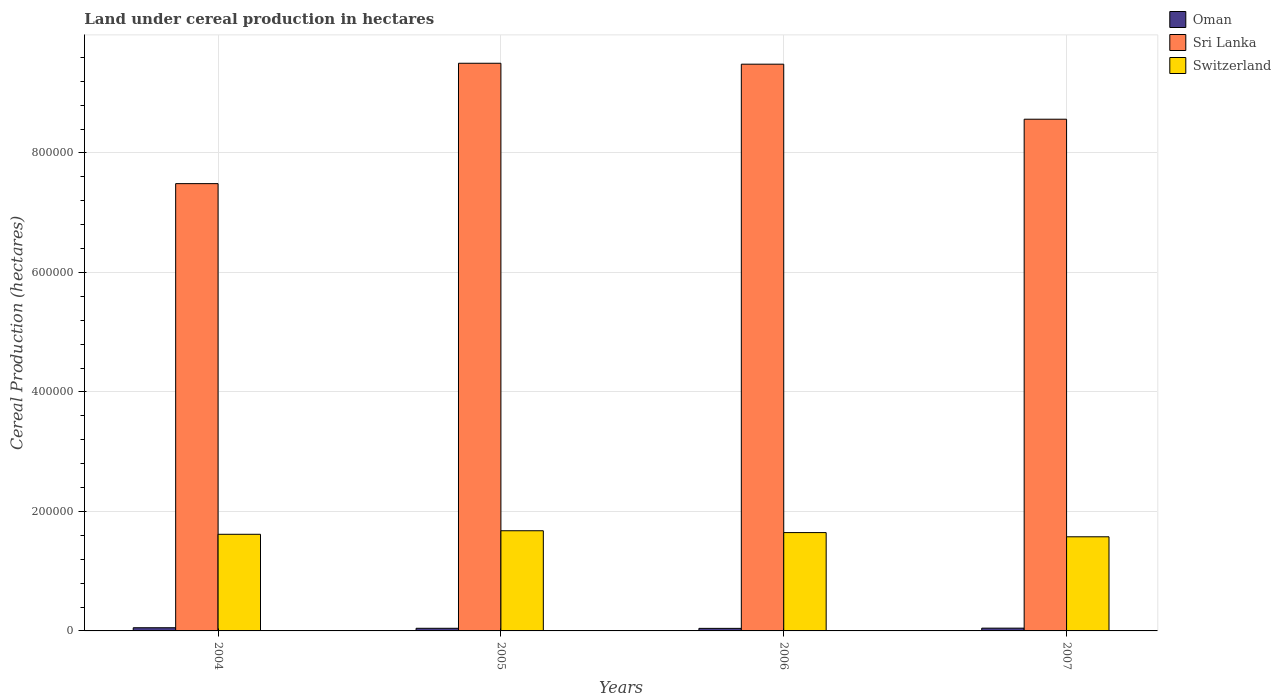How many different coloured bars are there?
Offer a terse response. 3. What is the label of the 1st group of bars from the left?
Your answer should be very brief. 2004. What is the land under cereal production in Switzerland in 2007?
Your response must be concise. 1.58e+05. Across all years, what is the maximum land under cereal production in Sri Lanka?
Keep it short and to the point. 9.50e+05. Across all years, what is the minimum land under cereal production in Switzerland?
Your answer should be very brief. 1.58e+05. What is the total land under cereal production in Switzerland in the graph?
Your answer should be very brief. 6.52e+05. What is the difference between the land under cereal production in Oman in 2006 and that in 2007?
Ensure brevity in your answer.  -363.4. What is the difference between the land under cereal production in Oman in 2007 and the land under cereal production in Switzerland in 2006?
Offer a terse response. -1.60e+05. What is the average land under cereal production in Switzerland per year?
Ensure brevity in your answer.  1.63e+05. In the year 2004, what is the difference between the land under cereal production in Sri Lanka and land under cereal production in Oman?
Offer a terse response. 7.43e+05. In how many years, is the land under cereal production in Oman greater than 800000 hectares?
Make the answer very short. 0. What is the ratio of the land under cereal production in Oman in 2005 to that in 2006?
Your answer should be compact. 1.03. What is the difference between the highest and the second highest land under cereal production in Oman?
Keep it short and to the point. 674.5. What is the difference between the highest and the lowest land under cereal production in Switzerland?
Your answer should be very brief. 1.01e+04. In how many years, is the land under cereal production in Oman greater than the average land under cereal production in Oman taken over all years?
Your response must be concise. 1. Is the sum of the land under cereal production in Oman in 2004 and 2006 greater than the maximum land under cereal production in Sri Lanka across all years?
Provide a short and direct response. No. What does the 1st bar from the left in 2005 represents?
Keep it short and to the point. Oman. What does the 2nd bar from the right in 2007 represents?
Provide a short and direct response. Sri Lanka. Is it the case that in every year, the sum of the land under cereal production in Sri Lanka and land under cereal production in Oman is greater than the land under cereal production in Switzerland?
Your answer should be very brief. Yes. How many years are there in the graph?
Offer a very short reply. 4. What is the difference between two consecutive major ticks on the Y-axis?
Your answer should be very brief. 2.00e+05. Does the graph contain grids?
Your answer should be very brief. Yes. Where does the legend appear in the graph?
Offer a terse response. Top right. How many legend labels are there?
Provide a short and direct response. 3. What is the title of the graph?
Keep it short and to the point. Land under cereal production in hectares. What is the label or title of the X-axis?
Provide a succinct answer. Years. What is the label or title of the Y-axis?
Give a very brief answer. Cereal Production (hectares). What is the Cereal Production (hectares) in Oman in 2004?
Your answer should be very brief. 5317.5. What is the Cereal Production (hectares) in Sri Lanka in 2004?
Your response must be concise. 7.49e+05. What is the Cereal Production (hectares) in Switzerland in 2004?
Provide a short and direct response. 1.62e+05. What is the Cereal Production (hectares) in Oman in 2005?
Make the answer very short. 4393.6. What is the Cereal Production (hectares) in Sri Lanka in 2005?
Your answer should be very brief. 9.50e+05. What is the Cereal Production (hectares) of Switzerland in 2005?
Your response must be concise. 1.68e+05. What is the Cereal Production (hectares) in Oman in 2006?
Provide a short and direct response. 4279.6. What is the Cereal Production (hectares) of Sri Lanka in 2006?
Make the answer very short. 9.49e+05. What is the Cereal Production (hectares) in Switzerland in 2006?
Provide a short and direct response. 1.65e+05. What is the Cereal Production (hectares) of Oman in 2007?
Your response must be concise. 4643. What is the Cereal Production (hectares) of Sri Lanka in 2007?
Ensure brevity in your answer.  8.57e+05. What is the Cereal Production (hectares) in Switzerland in 2007?
Provide a succinct answer. 1.58e+05. Across all years, what is the maximum Cereal Production (hectares) in Oman?
Make the answer very short. 5317.5. Across all years, what is the maximum Cereal Production (hectares) in Sri Lanka?
Your answer should be compact. 9.50e+05. Across all years, what is the maximum Cereal Production (hectares) of Switzerland?
Your response must be concise. 1.68e+05. Across all years, what is the minimum Cereal Production (hectares) in Oman?
Your response must be concise. 4279.6. Across all years, what is the minimum Cereal Production (hectares) of Sri Lanka?
Give a very brief answer. 7.49e+05. Across all years, what is the minimum Cereal Production (hectares) in Switzerland?
Make the answer very short. 1.58e+05. What is the total Cereal Production (hectares) of Oman in the graph?
Provide a short and direct response. 1.86e+04. What is the total Cereal Production (hectares) in Sri Lanka in the graph?
Your answer should be very brief. 3.50e+06. What is the total Cereal Production (hectares) in Switzerland in the graph?
Keep it short and to the point. 6.52e+05. What is the difference between the Cereal Production (hectares) of Oman in 2004 and that in 2005?
Your answer should be compact. 923.9. What is the difference between the Cereal Production (hectares) of Sri Lanka in 2004 and that in 2005?
Provide a succinct answer. -2.01e+05. What is the difference between the Cereal Production (hectares) in Switzerland in 2004 and that in 2005?
Provide a succinct answer. -5936. What is the difference between the Cereal Production (hectares) in Oman in 2004 and that in 2006?
Offer a terse response. 1037.9. What is the difference between the Cereal Production (hectares) of Sri Lanka in 2004 and that in 2006?
Your answer should be very brief. -2.00e+05. What is the difference between the Cereal Production (hectares) in Switzerland in 2004 and that in 2006?
Make the answer very short. -2837. What is the difference between the Cereal Production (hectares) of Oman in 2004 and that in 2007?
Ensure brevity in your answer.  674.5. What is the difference between the Cereal Production (hectares) of Sri Lanka in 2004 and that in 2007?
Your answer should be compact. -1.08e+05. What is the difference between the Cereal Production (hectares) of Switzerland in 2004 and that in 2007?
Your response must be concise. 4181. What is the difference between the Cereal Production (hectares) of Oman in 2005 and that in 2006?
Give a very brief answer. 114. What is the difference between the Cereal Production (hectares) in Sri Lanka in 2005 and that in 2006?
Offer a very short reply. 1537. What is the difference between the Cereal Production (hectares) in Switzerland in 2005 and that in 2006?
Offer a terse response. 3099. What is the difference between the Cereal Production (hectares) in Oman in 2005 and that in 2007?
Provide a short and direct response. -249.4. What is the difference between the Cereal Production (hectares) of Sri Lanka in 2005 and that in 2007?
Your response must be concise. 9.37e+04. What is the difference between the Cereal Production (hectares) of Switzerland in 2005 and that in 2007?
Your response must be concise. 1.01e+04. What is the difference between the Cereal Production (hectares) of Oman in 2006 and that in 2007?
Your response must be concise. -363.4. What is the difference between the Cereal Production (hectares) in Sri Lanka in 2006 and that in 2007?
Make the answer very short. 9.21e+04. What is the difference between the Cereal Production (hectares) of Switzerland in 2006 and that in 2007?
Provide a succinct answer. 7018. What is the difference between the Cereal Production (hectares) of Oman in 2004 and the Cereal Production (hectares) of Sri Lanka in 2005?
Ensure brevity in your answer.  -9.45e+05. What is the difference between the Cereal Production (hectares) of Oman in 2004 and the Cereal Production (hectares) of Switzerland in 2005?
Provide a short and direct response. -1.62e+05. What is the difference between the Cereal Production (hectares) of Sri Lanka in 2004 and the Cereal Production (hectares) of Switzerland in 2005?
Provide a short and direct response. 5.81e+05. What is the difference between the Cereal Production (hectares) in Oman in 2004 and the Cereal Production (hectares) in Sri Lanka in 2006?
Keep it short and to the point. -9.43e+05. What is the difference between the Cereal Production (hectares) in Oman in 2004 and the Cereal Production (hectares) in Switzerland in 2006?
Offer a very short reply. -1.59e+05. What is the difference between the Cereal Production (hectares) of Sri Lanka in 2004 and the Cereal Production (hectares) of Switzerland in 2006?
Keep it short and to the point. 5.84e+05. What is the difference between the Cereal Production (hectares) in Oman in 2004 and the Cereal Production (hectares) in Sri Lanka in 2007?
Keep it short and to the point. -8.51e+05. What is the difference between the Cereal Production (hectares) in Oman in 2004 and the Cereal Production (hectares) in Switzerland in 2007?
Give a very brief answer. -1.52e+05. What is the difference between the Cereal Production (hectares) of Sri Lanka in 2004 and the Cereal Production (hectares) of Switzerland in 2007?
Offer a very short reply. 5.91e+05. What is the difference between the Cereal Production (hectares) in Oman in 2005 and the Cereal Production (hectares) in Sri Lanka in 2006?
Offer a very short reply. -9.44e+05. What is the difference between the Cereal Production (hectares) in Oman in 2005 and the Cereal Production (hectares) in Switzerland in 2006?
Your answer should be compact. -1.60e+05. What is the difference between the Cereal Production (hectares) in Sri Lanka in 2005 and the Cereal Production (hectares) in Switzerland in 2006?
Offer a terse response. 7.86e+05. What is the difference between the Cereal Production (hectares) of Oman in 2005 and the Cereal Production (hectares) of Sri Lanka in 2007?
Provide a short and direct response. -8.52e+05. What is the difference between the Cereal Production (hectares) of Oman in 2005 and the Cereal Production (hectares) of Switzerland in 2007?
Provide a short and direct response. -1.53e+05. What is the difference between the Cereal Production (hectares) in Sri Lanka in 2005 and the Cereal Production (hectares) in Switzerland in 2007?
Ensure brevity in your answer.  7.93e+05. What is the difference between the Cereal Production (hectares) in Oman in 2006 and the Cereal Production (hectares) in Sri Lanka in 2007?
Your answer should be compact. -8.52e+05. What is the difference between the Cereal Production (hectares) of Oman in 2006 and the Cereal Production (hectares) of Switzerland in 2007?
Offer a terse response. -1.53e+05. What is the difference between the Cereal Production (hectares) of Sri Lanka in 2006 and the Cereal Production (hectares) of Switzerland in 2007?
Make the answer very short. 7.91e+05. What is the average Cereal Production (hectares) in Oman per year?
Your answer should be very brief. 4658.43. What is the average Cereal Production (hectares) in Sri Lanka per year?
Keep it short and to the point. 8.76e+05. What is the average Cereal Production (hectares) of Switzerland per year?
Your answer should be very brief. 1.63e+05. In the year 2004, what is the difference between the Cereal Production (hectares) in Oman and Cereal Production (hectares) in Sri Lanka?
Offer a very short reply. -7.43e+05. In the year 2004, what is the difference between the Cereal Production (hectares) of Oman and Cereal Production (hectares) of Switzerland?
Offer a terse response. -1.56e+05. In the year 2004, what is the difference between the Cereal Production (hectares) in Sri Lanka and Cereal Production (hectares) in Switzerland?
Offer a terse response. 5.87e+05. In the year 2005, what is the difference between the Cereal Production (hectares) in Oman and Cereal Production (hectares) in Sri Lanka?
Provide a short and direct response. -9.46e+05. In the year 2005, what is the difference between the Cereal Production (hectares) of Oman and Cereal Production (hectares) of Switzerland?
Ensure brevity in your answer.  -1.63e+05. In the year 2005, what is the difference between the Cereal Production (hectares) of Sri Lanka and Cereal Production (hectares) of Switzerland?
Make the answer very short. 7.83e+05. In the year 2006, what is the difference between the Cereal Production (hectares) in Oman and Cereal Production (hectares) in Sri Lanka?
Your answer should be very brief. -9.44e+05. In the year 2006, what is the difference between the Cereal Production (hectares) in Oman and Cereal Production (hectares) in Switzerland?
Your response must be concise. -1.60e+05. In the year 2006, what is the difference between the Cereal Production (hectares) in Sri Lanka and Cereal Production (hectares) in Switzerland?
Offer a very short reply. 7.84e+05. In the year 2007, what is the difference between the Cereal Production (hectares) of Oman and Cereal Production (hectares) of Sri Lanka?
Provide a short and direct response. -8.52e+05. In the year 2007, what is the difference between the Cereal Production (hectares) of Oman and Cereal Production (hectares) of Switzerland?
Give a very brief answer. -1.53e+05. In the year 2007, what is the difference between the Cereal Production (hectares) in Sri Lanka and Cereal Production (hectares) in Switzerland?
Provide a short and direct response. 6.99e+05. What is the ratio of the Cereal Production (hectares) of Oman in 2004 to that in 2005?
Your answer should be very brief. 1.21. What is the ratio of the Cereal Production (hectares) of Sri Lanka in 2004 to that in 2005?
Offer a very short reply. 0.79. What is the ratio of the Cereal Production (hectares) of Switzerland in 2004 to that in 2005?
Ensure brevity in your answer.  0.96. What is the ratio of the Cereal Production (hectares) of Oman in 2004 to that in 2006?
Your answer should be compact. 1.24. What is the ratio of the Cereal Production (hectares) in Sri Lanka in 2004 to that in 2006?
Ensure brevity in your answer.  0.79. What is the ratio of the Cereal Production (hectares) in Switzerland in 2004 to that in 2006?
Your response must be concise. 0.98. What is the ratio of the Cereal Production (hectares) of Oman in 2004 to that in 2007?
Provide a succinct answer. 1.15. What is the ratio of the Cereal Production (hectares) of Sri Lanka in 2004 to that in 2007?
Offer a terse response. 0.87. What is the ratio of the Cereal Production (hectares) in Switzerland in 2004 to that in 2007?
Offer a very short reply. 1.03. What is the ratio of the Cereal Production (hectares) of Oman in 2005 to that in 2006?
Offer a very short reply. 1.03. What is the ratio of the Cereal Production (hectares) of Sri Lanka in 2005 to that in 2006?
Offer a terse response. 1. What is the ratio of the Cereal Production (hectares) in Switzerland in 2005 to that in 2006?
Offer a terse response. 1.02. What is the ratio of the Cereal Production (hectares) in Oman in 2005 to that in 2007?
Keep it short and to the point. 0.95. What is the ratio of the Cereal Production (hectares) in Sri Lanka in 2005 to that in 2007?
Ensure brevity in your answer.  1.11. What is the ratio of the Cereal Production (hectares) of Switzerland in 2005 to that in 2007?
Ensure brevity in your answer.  1.06. What is the ratio of the Cereal Production (hectares) in Oman in 2006 to that in 2007?
Offer a very short reply. 0.92. What is the ratio of the Cereal Production (hectares) of Sri Lanka in 2006 to that in 2007?
Provide a succinct answer. 1.11. What is the ratio of the Cereal Production (hectares) of Switzerland in 2006 to that in 2007?
Make the answer very short. 1.04. What is the difference between the highest and the second highest Cereal Production (hectares) of Oman?
Provide a short and direct response. 674.5. What is the difference between the highest and the second highest Cereal Production (hectares) of Sri Lanka?
Your answer should be compact. 1537. What is the difference between the highest and the second highest Cereal Production (hectares) of Switzerland?
Offer a terse response. 3099. What is the difference between the highest and the lowest Cereal Production (hectares) in Oman?
Your answer should be compact. 1037.9. What is the difference between the highest and the lowest Cereal Production (hectares) of Sri Lanka?
Provide a short and direct response. 2.01e+05. What is the difference between the highest and the lowest Cereal Production (hectares) in Switzerland?
Your answer should be compact. 1.01e+04. 